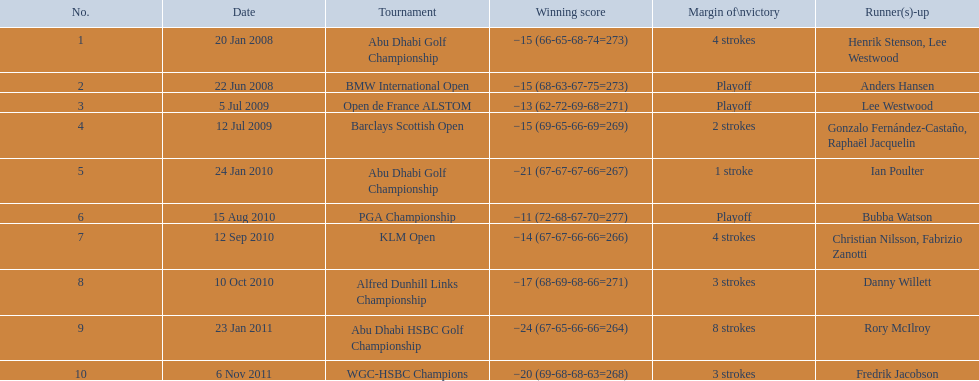I'm looking to parse the entire table for insights. Could you assist me with that? {'header': ['No.', 'Date', 'Tournament', 'Winning score', 'Margin of\\nvictory', 'Runner(s)-up'], 'rows': [['1', '20 Jan 2008', 'Abu Dhabi Golf Championship', '−15 (66-65-68-74=273)', '4 strokes', 'Henrik Stenson, Lee Westwood'], ['2', '22 Jun 2008', 'BMW International Open', '−15 (68-63-67-75=273)', 'Playoff', 'Anders Hansen'], ['3', '5 Jul 2009', 'Open de France ALSTOM', '−13 (62-72-69-68=271)', 'Playoff', 'Lee Westwood'], ['4', '12 Jul 2009', 'Barclays Scottish Open', '−15 (69-65-66-69=269)', '2 strokes', 'Gonzalo Fernández-Castaño, Raphaël Jacquelin'], ['5', '24 Jan 2010', 'Abu Dhabi Golf Championship', '−21 (67-67-67-66=267)', '1 stroke', 'Ian Poulter'], ['6', '15 Aug 2010', 'PGA Championship', '−11 (72-68-67-70=277)', 'Playoff', 'Bubba Watson'], ['7', '12 Sep 2010', 'KLM Open', '−14 (67-67-66-66=266)', '4 strokes', 'Christian Nilsson, Fabrizio Zanotti'], ['8', '10 Oct 2010', 'Alfred Dunhill Links Championship', '−17 (68-69-68-66=271)', '3 strokes', 'Danny Willett'], ['9', '23 Jan 2011', 'Abu Dhabi HSBC Golf Championship', '−24 (67-65-66-66=264)', '8 strokes', 'Rory McIlroy'], ['10', '6 Nov 2011', 'WGC-HSBC Champions', '−20 (69-68-68-63=268)', '3 strokes', 'Fredrik Jacobson']]} What were all the different tournaments played by martin kaymer Abu Dhabi Golf Championship, BMW International Open, Open de France ALSTOM, Barclays Scottish Open, Abu Dhabi Golf Championship, PGA Championship, KLM Open, Alfred Dunhill Links Championship, Abu Dhabi HSBC Golf Championship, WGC-HSBC Champions. Who was the runner-up for the pga championship? Bubba Watson. 